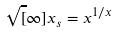Convert formula to latex. <formula><loc_0><loc_0><loc_500><loc_500>\sqrt { [ } \infty ] { x } _ { s } = x ^ { 1 / x }</formula> 